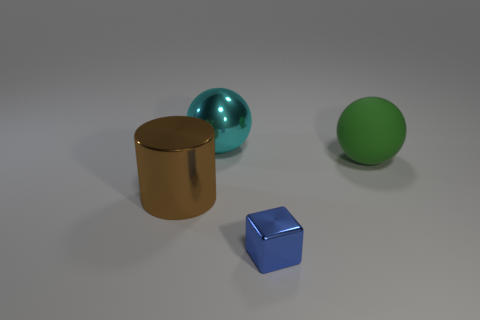Are there any other things that have the same size as the metal cube?
Offer a terse response. No. Are there any brown rubber cylinders of the same size as the green ball?
Your response must be concise. No. Are there fewer cyan metal balls to the left of the big cyan metal sphere than large cylinders?
Ensure brevity in your answer.  Yes. There is a large sphere in front of the big metallic object that is right of the big metal object that is in front of the green rubber sphere; what is it made of?
Give a very brief answer. Rubber. Is the number of spheres behind the big matte ball greater than the number of tiny blue blocks on the left side of the big cyan shiny thing?
Keep it short and to the point. Yes. What number of metal things are either tiny things or small green blocks?
Make the answer very short. 1. What is the large green thing that is right of the tiny block made of?
Provide a succinct answer. Rubber. How many things are either red metallic balls or blue shiny blocks that are in front of the cyan ball?
Your answer should be compact. 1. There is another matte thing that is the same size as the brown thing; what shape is it?
Your answer should be compact. Sphere. How many small shiny cubes have the same color as the rubber sphere?
Keep it short and to the point. 0. 